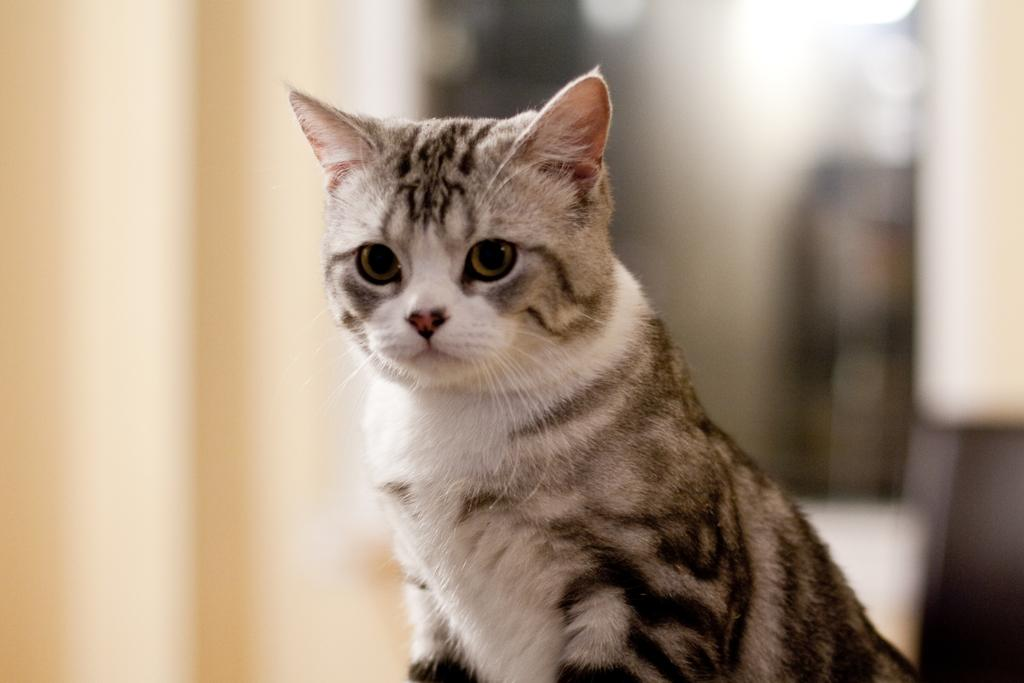What is the main subject in the center of the image? There is a cat in the center of the image. What type of magic does the cat perform in the image? There is no magic or any magical actions performed by the cat in the image. 